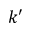<formula> <loc_0><loc_0><loc_500><loc_500>k ^ { \prime }</formula> 